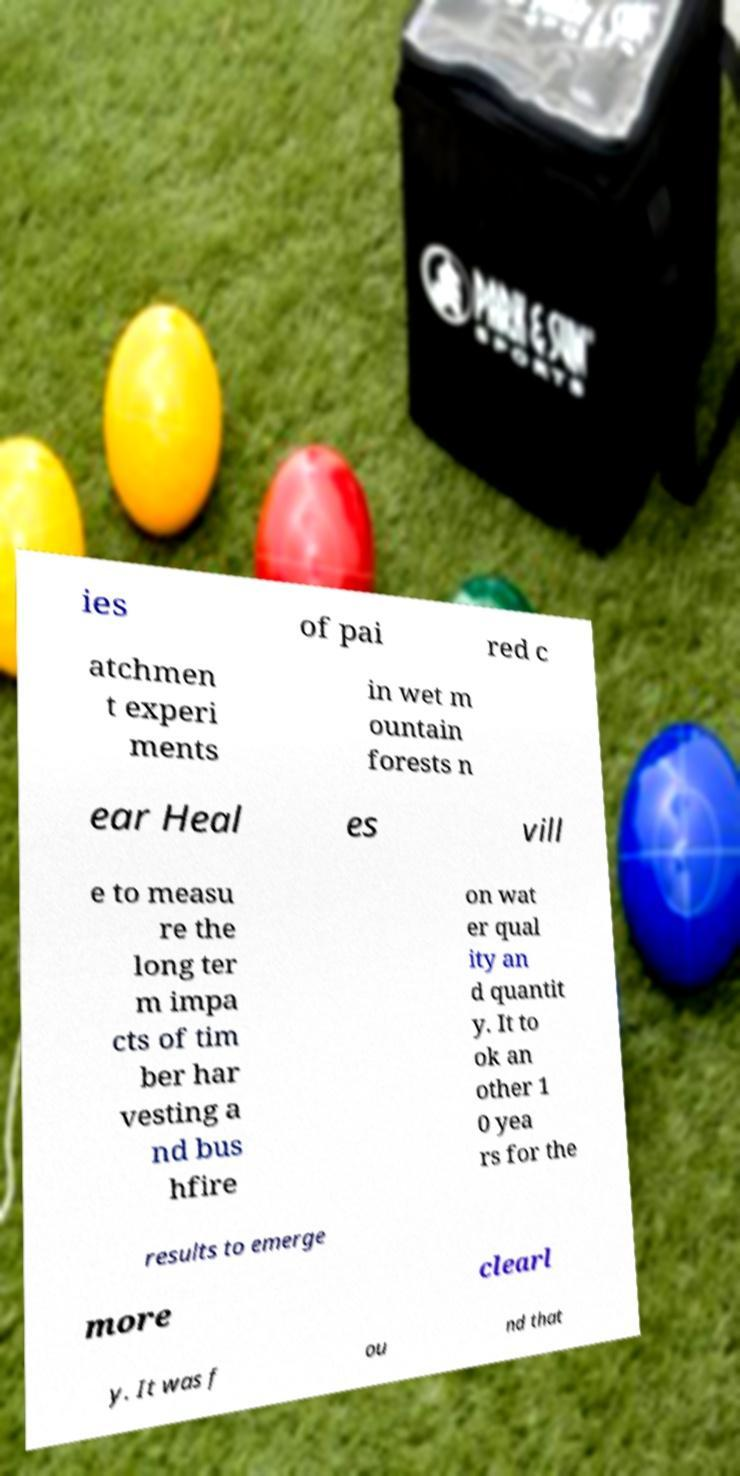Can you accurately transcribe the text from the provided image for me? ies of pai red c atchmen t experi ments in wet m ountain forests n ear Heal es vill e to measu re the long ter m impa cts of tim ber har vesting a nd bus hfire on wat er qual ity an d quantit y. It to ok an other 1 0 yea rs for the results to emerge more clearl y. It was f ou nd that 